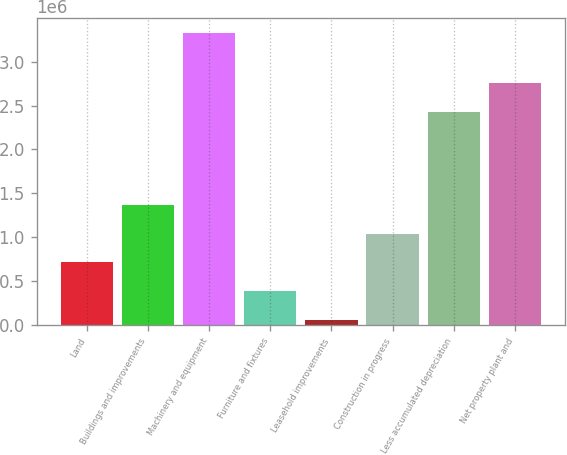Convert chart. <chart><loc_0><loc_0><loc_500><loc_500><bar_chart><fcel>Land<fcel>Buildings and improvements<fcel>Machinery and equipment<fcel>Furniture and fixtures<fcel>Leasehold improvements<fcel>Construction in progress<fcel>Less accumulated depreciation<fcel>Net property plant and<nl><fcel>716119<fcel>1.36825e+06<fcel>3.32466e+06<fcel>390052<fcel>63985<fcel>1.04219e+06<fcel>2.427e+06<fcel>2.75307e+06<nl></chart> 